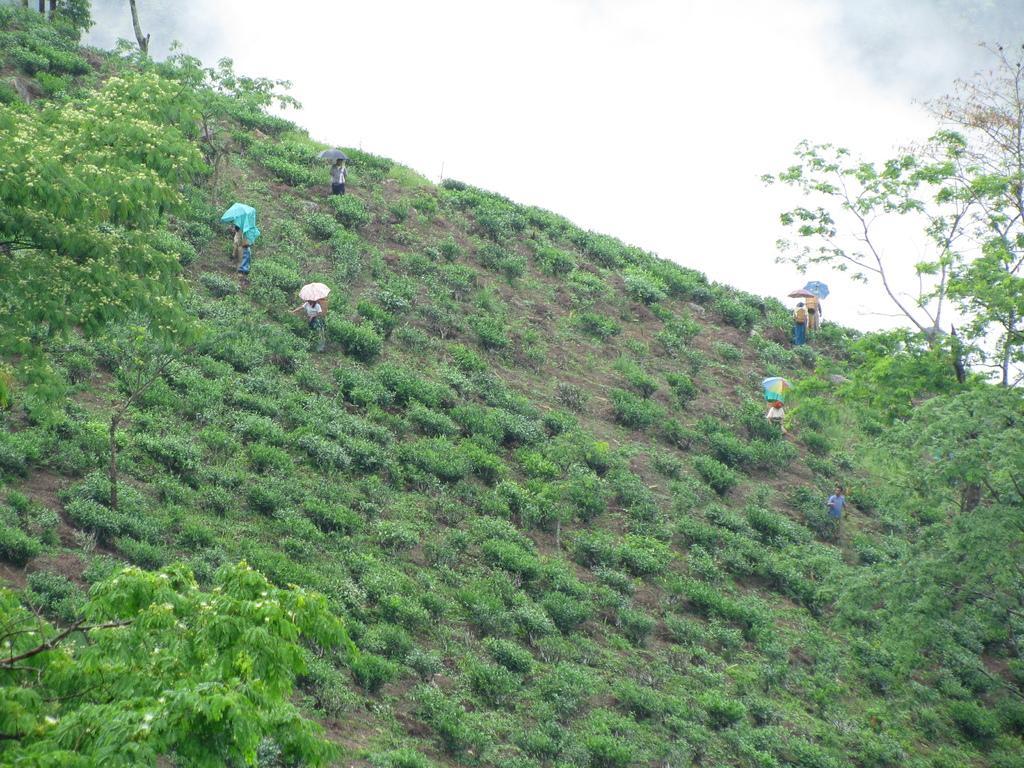Can you describe this image briefly? In this image I can see people are present on the grass, holding umbrellas. There are trees and there is sky at the top. 